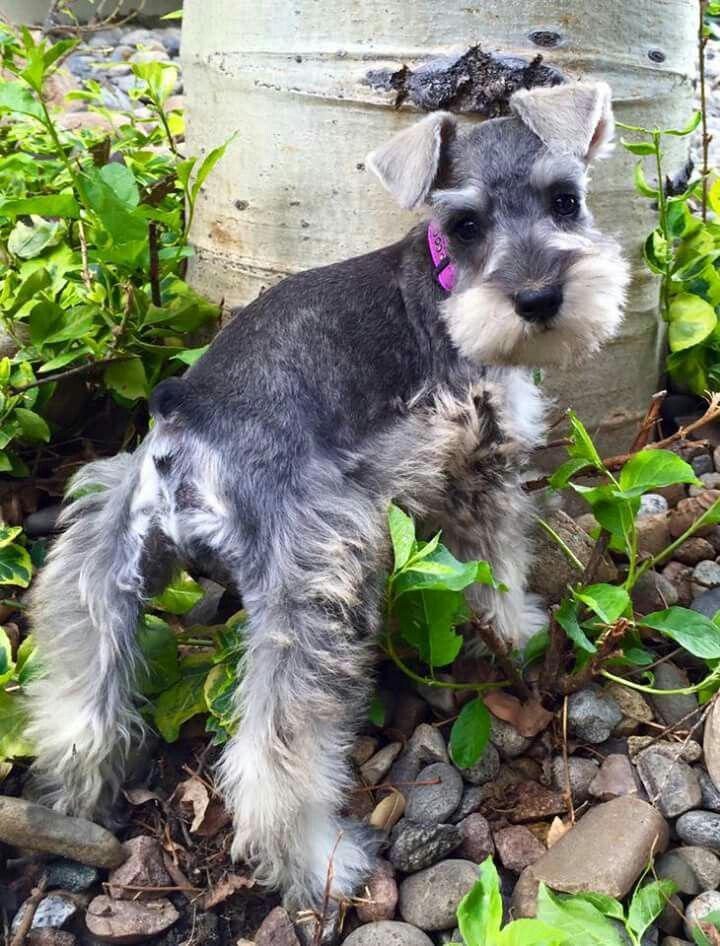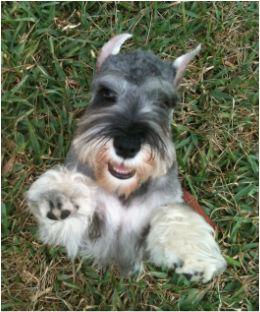The first image is the image on the left, the second image is the image on the right. Considering the images on both sides, is "There are no more than four dogs" valid? Answer yes or no. Yes. 